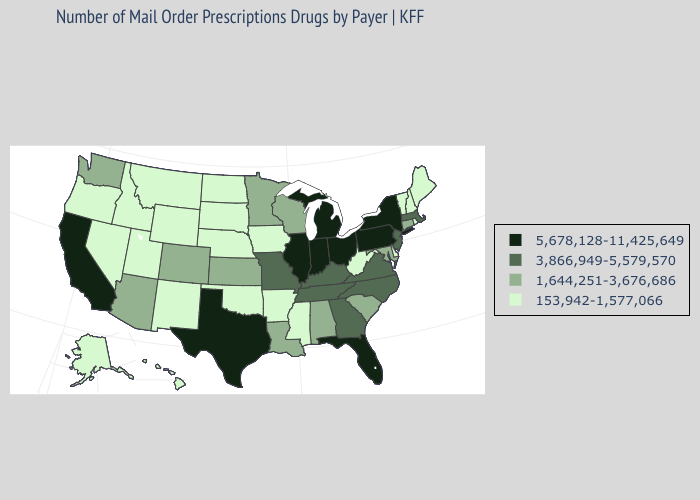What is the value of Nevada?
Concise answer only. 153,942-1,577,066. Name the states that have a value in the range 3,866,949-5,579,570?
Be succinct. Georgia, Kentucky, Massachusetts, Missouri, New Jersey, North Carolina, Tennessee, Virginia. What is the highest value in the USA?
Keep it brief. 5,678,128-11,425,649. Among the states that border Mississippi , does Arkansas have the highest value?
Quick response, please. No. What is the value of South Dakota?
Answer briefly. 153,942-1,577,066. Does Michigan have the lowest value in the USA?
Answer briefly. No. Among the states that border Delaware , which have the lowest value?
Write a very short answer. Maryland. Name the states that have a value in the range 1,644,251-3,676,686?
Concise answer only. Alabama, Arizona, Colorado, Connecticut, Kansas, Louisiana, Maryland, Minnesota, South Carolina, Washington, Wisconsin. What is the value of Tennessee?
Quick response, please. 3,866,949-5,579,570. What is the lowest value in the South?
Be succinct. 153,942-1,577,066. What is the value of California?
Quick response, please. 5,678,128-11,425,649. Name the states that have a value in the range 3,866,949-5,579,570?
Give a very brief answer. Georgia, Kentucky, Massachusetts, Missouri, New Jersey, North Carolina, Tennessee, Virginia. What is the value of Virginia?
Concise answer only. 3,866,949-5,579,570. Does the first symbol in the legend represent the smallest category?
Concise answer only. No. Which states hav the highest value in the Northeast?
Be succinct. New York, Pennsylvania. 